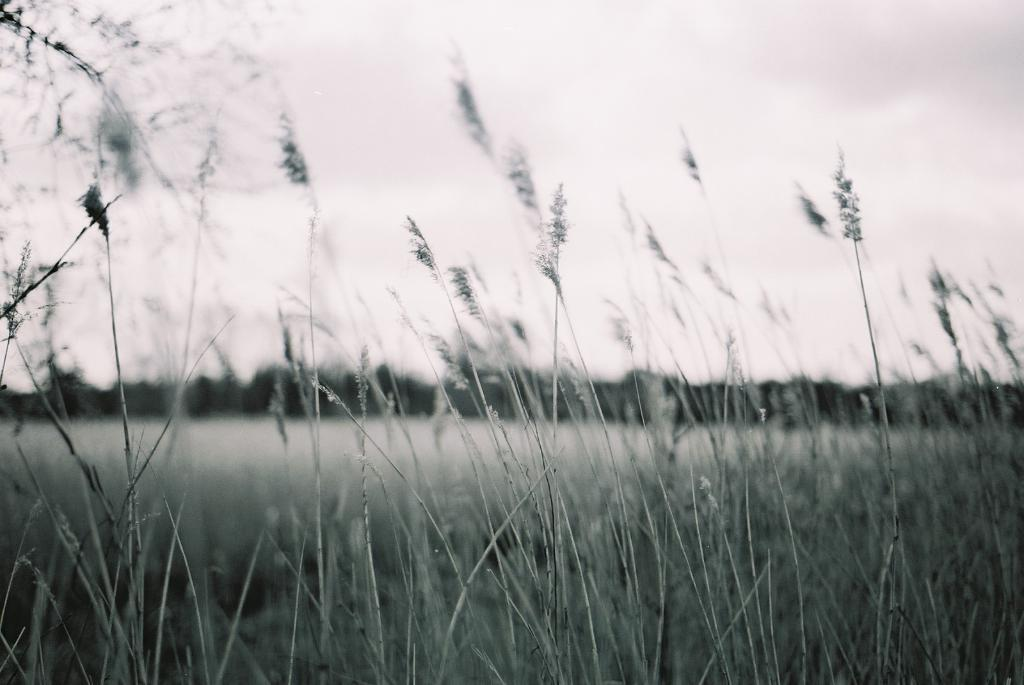What type of vegetation is in the foreground of the image? There is grass in the foreground of the image. What can be seen in the background of the image? There are trees and the sky visible in the background of the image. What type of vest is hanging on the tree in the image? There is no vest present in the image; it only features grass, trees, and the sky. 